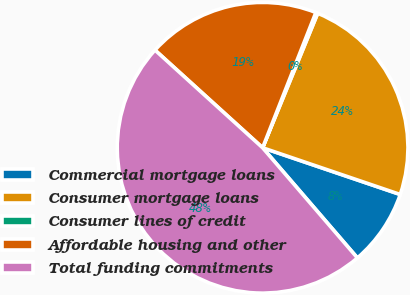<chart> <loc_0><loc_0><loc_500><loc_500><pie_chart><fcel>Commercial mortgage loans<fcel>Consumer mortgage loans<fcel>Consumer lines of credit<fcel>Affordable housing and other<fcel>Total funding commitments<nl><fcel>8.48%<fcel>24.02%<fcel>0.22%<fcel>19.24%<fcel>48.04%<nl></chart> 